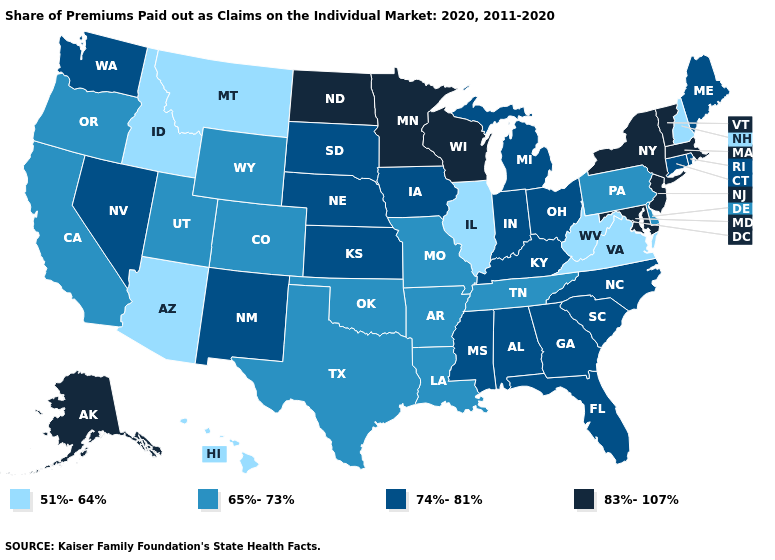What is the lowest value in states that border Pennsylvania?
Write a very short answer. 51%-64%. Does the map have missing data?
Keep it brief. No. What is the value of Vermont?
Short answer required. 83%-107%. Is the legend a continuous bar?
Short answer required. No. Name the states that have a value in the range 65%-73%?
Keep it brief. Arkansas, California, Colorado, Delaware, Louisiana, Missouri, Oklahoma, Oregon, Pennsylvania, Tennessee, Texas, Utah, Wyoming. Name the states that have a value in the range 51%-64%?
Write a very short answer. Arizona, Hawaii, Idaho, Illinois, Montana, New Hampshire, Virginia, West Virginia. Among the states that border West Virginia , which have the lowest value?
Answer briefly. Virginia. Does Montana have a lower value than Idaho?
Give a very brief answer. No. Name the states that have a value in the range 74%-81%?
Short answer required. Alabama, Connecticut, Florida, Georgia, Indiana, Iowa, Kansas, Kentucky, Maine, Michigan, Mississippi, Nebraska, Nevada, New Mexico, North Carolina, Ohio, Rhode Island, South Carolina, South Dakota, Washington. Name the states that have a value in the range 83%-107%?
Keep it brief. Alaska, Maryland, Massachusetts, Minnesota, New Jersey, New York, North Dakota, Vermont, Wisconsin. Name the states that have a value in the range 65%-73%?
Keep it brief. Arkansas, California, Colorado, Delaware, Louisiana, Missouri, Oklahoma, Oregon, Pennsylvania, Tennessee, Texas, Utah, Wyoming. Does Maine have the highest value in the Northeast?
Concise answer only. No. Does the map have missing data?
Short answer required. No. Among the states that border South Dakota , which have the highest value?
Quick response, please. Minnesota, North Dakota. 